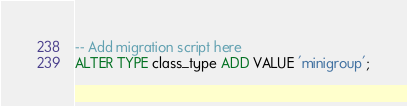Convert code to text. <code><loc_0><loc_0><loc_500><loc_500><_SQL_>-- Add migration script here
ALTER TYPE class_type ADD VALUE 'minigroup';
</code> 